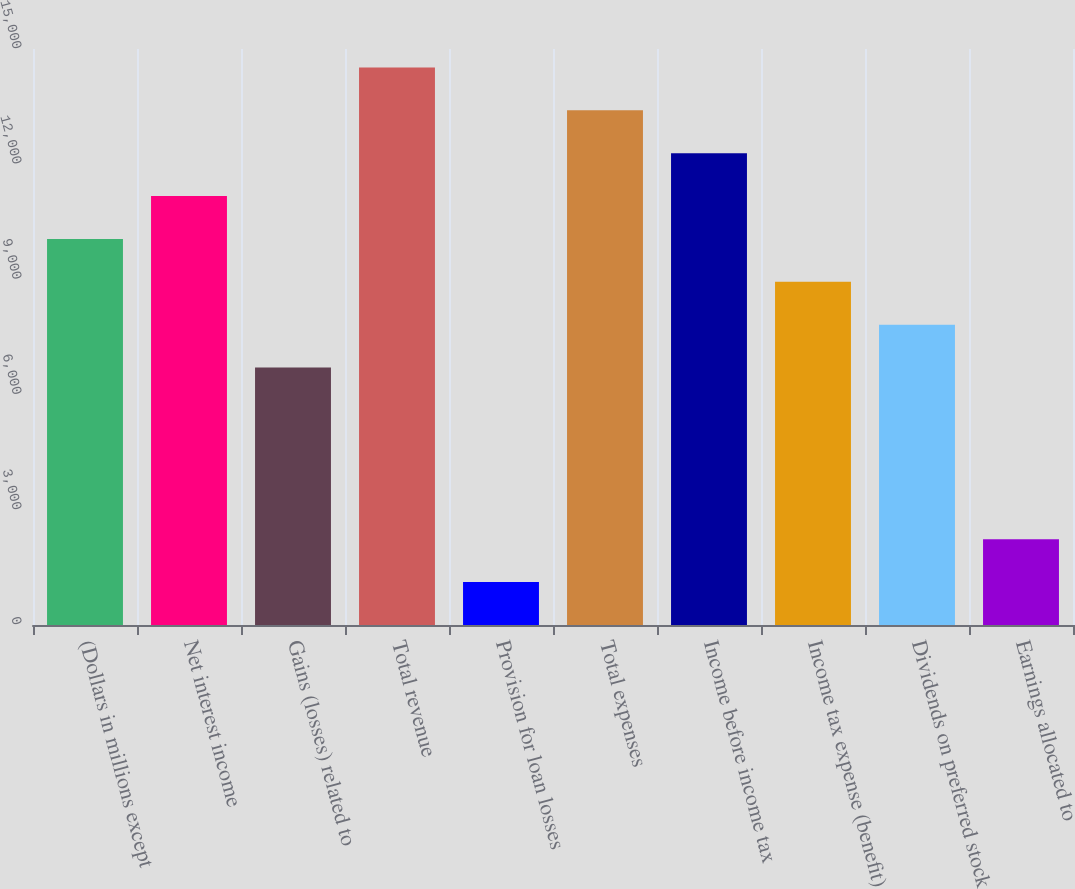Convert chart. <chart><loc_0><loc_0><loc_500><loc_500><bar_chart><fcel>(Dollars in millions except<fcel>Net interest income<fcel>Gains (losses) related to<fcel>Total revenue<fcel>Provision for loan losses<fcel>Total expenses<fcel>Income before income tax<fcel>Income tax expense (benefit)<fcel>Dividends on preferred stock<fcel>Earnings allocated to<nl><fcel>10053.2<fcel>11170<fcel>6702.64<fcel>14520.5<fcel>1118.44<fcel>13403.7<fcel>12286.8<fcel>8936.32<fcel>7819.48<fcel>2235.28<nl></chart> 